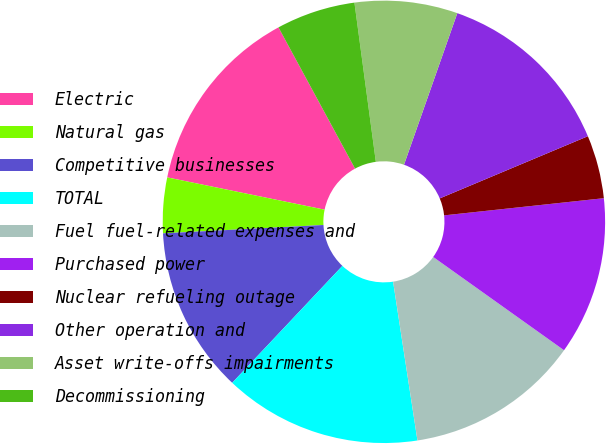<chart> <loc_0><loc_0><loc_500><loc_500><pie_chart><fcel>Electric<fcel>Natural gas<fcel>Competitive businesses<fcel>TOTAL<fcel>Fuel fuel-related expenses and<fcel>Purchased power<fcel>Nuclear refueling outage<fcel>Other operation and<fcel>Asset write-offs impairments<fcel>Decommissioning<nl><fcel>13.87%<fcel>4.05%<fcel>12.14%<fcel>14.45%<fcel>12.72%<fcel>11.56%<fcel>4.62%<fcel>13.29%<fcel>7.51%<fcel>5.78%<nl></chart> 